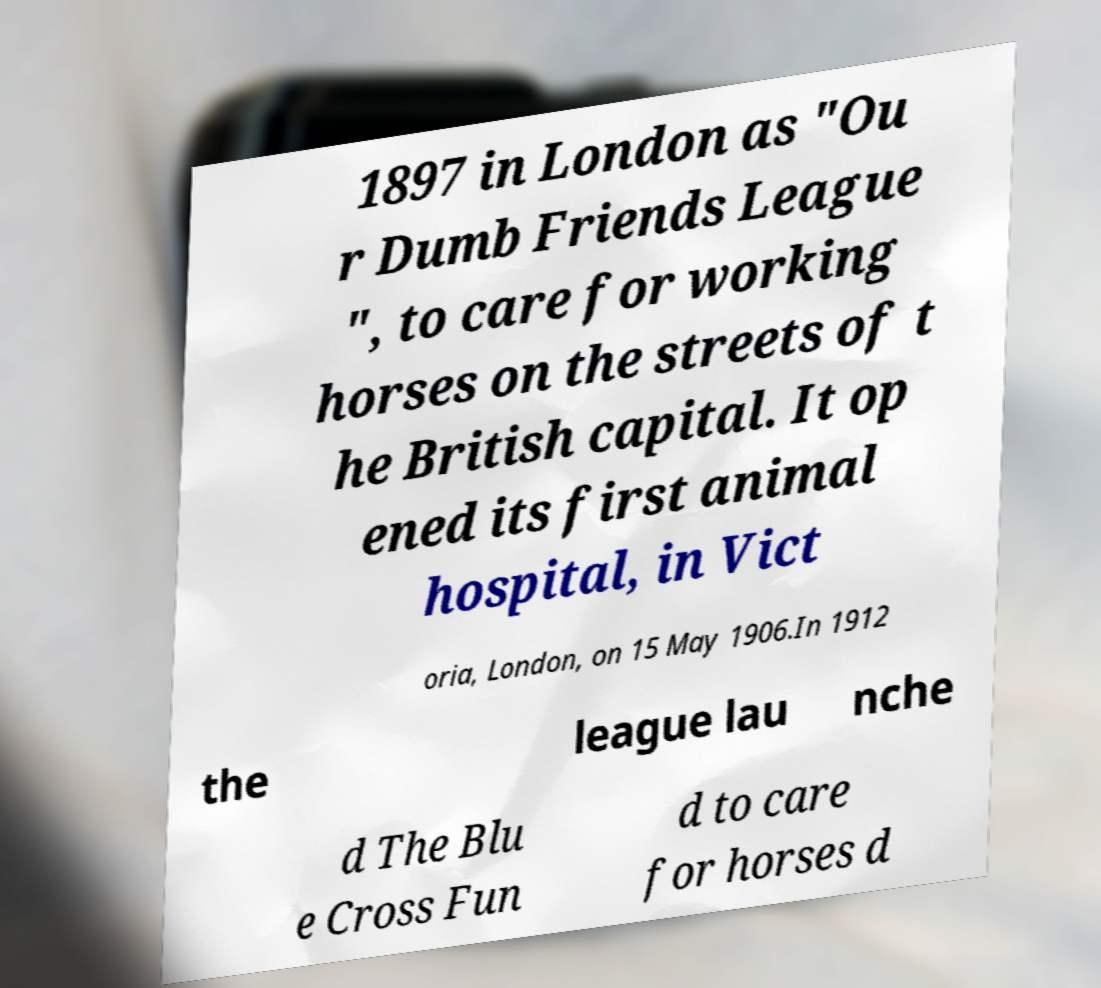Could you extract and type out the text from this image? 1897 in London as "Ou r Dumb Friends League ", to care for working horses on the streets of t he British capital. It op ened its first animal hospital, in Vict oria, London, on 15 May 1906.In 1912 the league lau nche d The Blu e Cross Fun d to care for horses d 